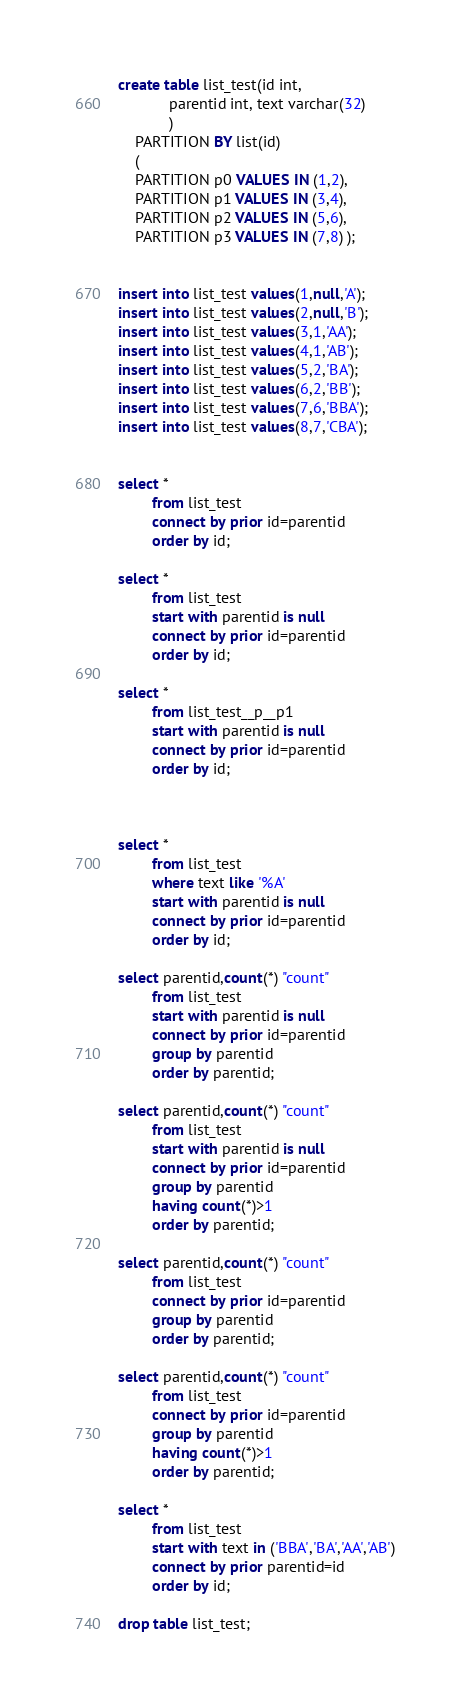Convert code to text. <code><loc_0><loc_0><loc_500><loc_500><_SQL_>create table list_test(id int,
			parentid int, text varchar(32)
			)
	PARTITION BY list(id)
	(
	PARTITION p0 VALUES IN (1,2),
	PARTITION p1 VALUES IN (3,4),
	PARTITION p2 VALUES IN (5,6),
	PARTITION p3 VALUES IN (7,8) );


insert into list_test values(1,null,'A');
insert into list_test values(2,null,'B');
insert into list_test values(3,1,'AA');
insert into list_test values(4,1,'AB');
insert into list_test values(5,2,'BA');
insert into list_test values(6,2,'BB');
insert into list_test values(7,6,'BBA');
insert into list_test values(8,7,'CBA');


select *
        from list_test
        connect by prior id=parentid
        order by id;

select *
        from list_test
        start with parentid is null
        connect by prior id=parentid
        order by id;

select *
        from list_test__p__p1
        start with parentid is null
        connect by prior id=parentid
        order by id;



select *
        from list_test
        where text like '%A'
        start with parentid is null
        connect by prior id=parentid
        order by id;

select parentid,count(*) "count"
        from list_test
        start with parentid is null
        connect by prior id=parentid
        group by parentid
        order by parentid;

select parentid,count(*) "count"
        from list_test
        start with parentid is null
        connect by prior id=parentid
        group by parentid
        having count(*)>1
        order by parentid;

select parentid,count(*) "count"
        from list_test
        connect by prior id=parentid
        group by parentid
        order by parentid;

select parentid,count(*) "count"
        from list_test
        connect by prior id=parentid
        group by parentid
        having count(*)>1
        order by parentid;

select *
        from list_test
        start with text in ('BBA','BA','AA','AB')
        connect by prior parentid=id
        order by id;

drop table list_test;
</code> 